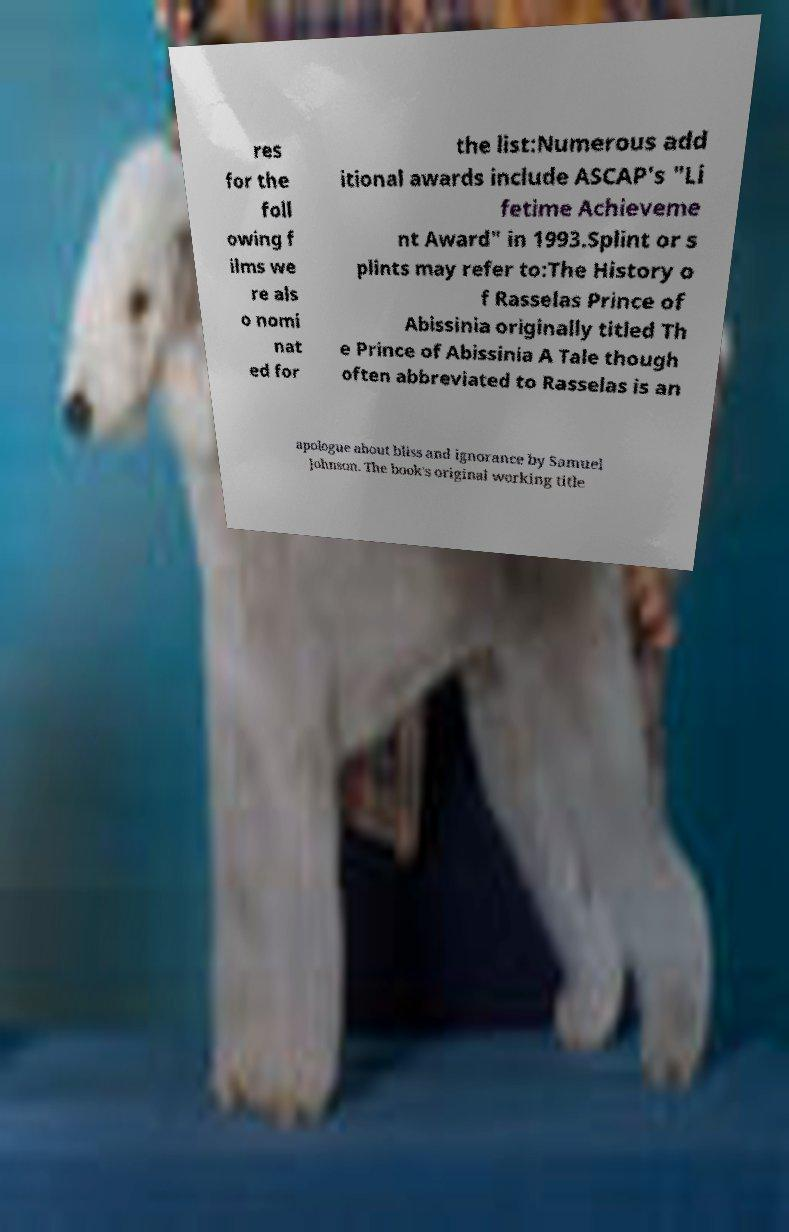Please identify and transcribe the text found in this image. res for the foll owing f ilms we re als o nomi nat ed for the list:Numerous add itional awards include ASCAP's "Li fetime Achieveme nt Award" in 1993.Splint or s plints may refer to:The History o f Rasselas Prince of Abissinia originally titled Th e Prince of Abissinia A Tale though often abbreviated to Rasselas is an apologue about bliss and ignorance by Samuel Johnson. The book's original working title 